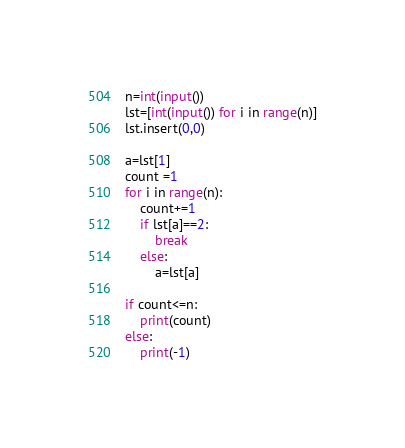<code> <loc_0><loc_0><loc_500><loc_500><_Python_>n=int(input())
lst=[int(input()) for i in range(n)]
lst.insert(0,0)

a=lst[1]
count =1
for i in range(n):
    count+=1
    if lst[a]==2:
        break
    else:
        a=lst[a]

if count<=n:
    print(count)
else:
    print(-1)</code> 